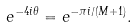Convert formula to latex. <formula><loc_0><loc_0><loc_500><loc_500>e ^ { - 4 i \theta } = e ^ { - \pi i / ( M + 1 ) } .</formula> 